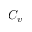<formula> <loc_0><loc_0><loc_500><loc_500>C _ { v }</formula> 